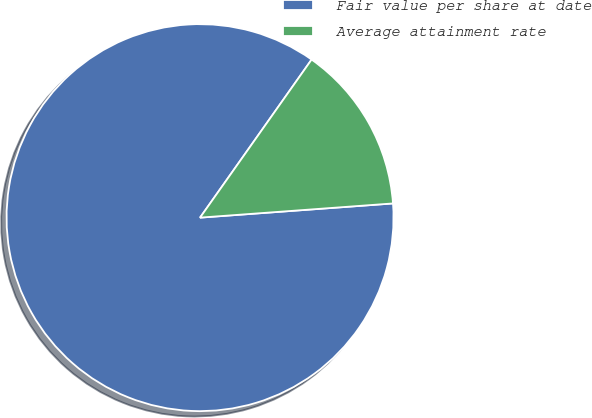<chart> <loc_0><loc_0><loc_500><loc_500><pie_chart><fcel>Fair value per share at date<fcel>Average attainment rate<nl><fcel>85.95%<fcel>14.05%<nl></chart> 